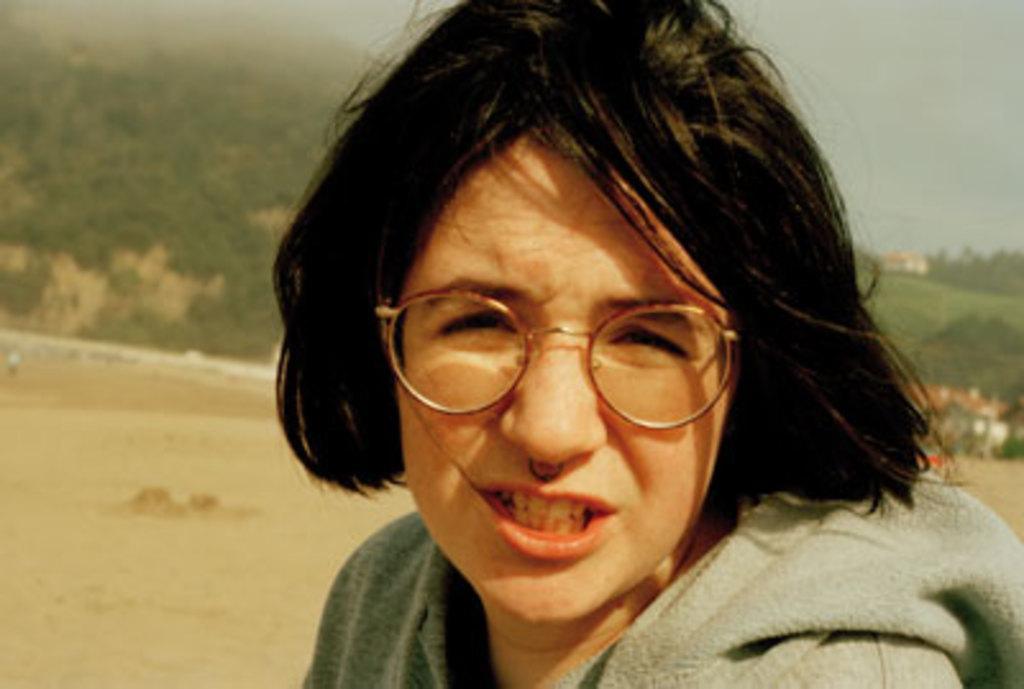Please provide a concise description of this image. In this image there is a lady on the ground behind her there is a mountain. 